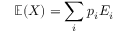<formula> <loc_0><loc_0><loc_500><loc_500>\mathbb { E } ( X ) = \sum _ { i } p _ { i } E _ { i }</formula> 